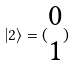<formula> <loc_0><loc_0><loc_500><loc_500>| 2 \rangle = ( \begin{matrix} 0 \\ 1 \end{matrix} )</formula> 